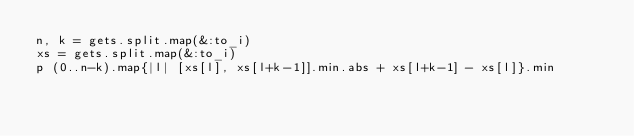<code> <loc_0><loc_0><loc_500><loc_500><_Ruby_>n, k = gets.split.map(&:to_i)
xs = gets.split.map(&:to_i)
p (0..n-k).map{|l| [xs[l], xs[l+k-1]].min.abs + xs[l+k-1] - xs[l]}.min</code> 